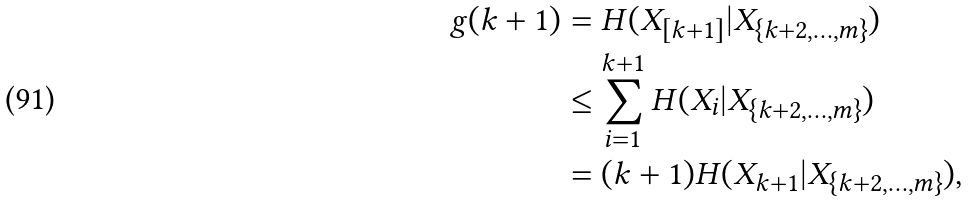Convert formula to latex. <formula><loc_0><loc_0><loc_500><loc_500>g ( k + 1 ) & = H ( X _ { [ k + 1 ] } | X _ { \{ k + 2 , \dots , m \} } ) \\ & \leq \sum _ { i = 1 } ^ { k + 1 } H ( X _ { i } | X _ { \{ k + 2 , \dots , m \} } ) \\ & = ( k + 1 ) H ( X _ { k + 1 } | X _ { \{ k + 2 , \dots , m \} } ) ,</formula> 